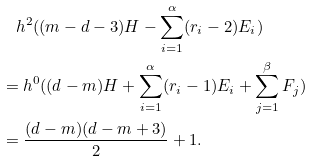Convert formula to latex. <formula><loc_0><loc_0><loc_500><loc_500>& \quad h ^ { 2 } ( ( m - d - 3 ) H - \sum _ { i = 1 } ^ { \alpha } ( r _ { i } - 2 ) E _ { i } ) \\ & = h ^ { 0 } ( ( d - m ) H + \sum _ { i = 1 } ^ { \alpha } ( r _ { i } - 1 ) E _ { i } + \sum _ { j = 1 } ^ { \beta } F _ { j } ) \\ & = \frac { ( d - m ) ( d - m + 3 ) } { 2 } + 1 .</formula> 